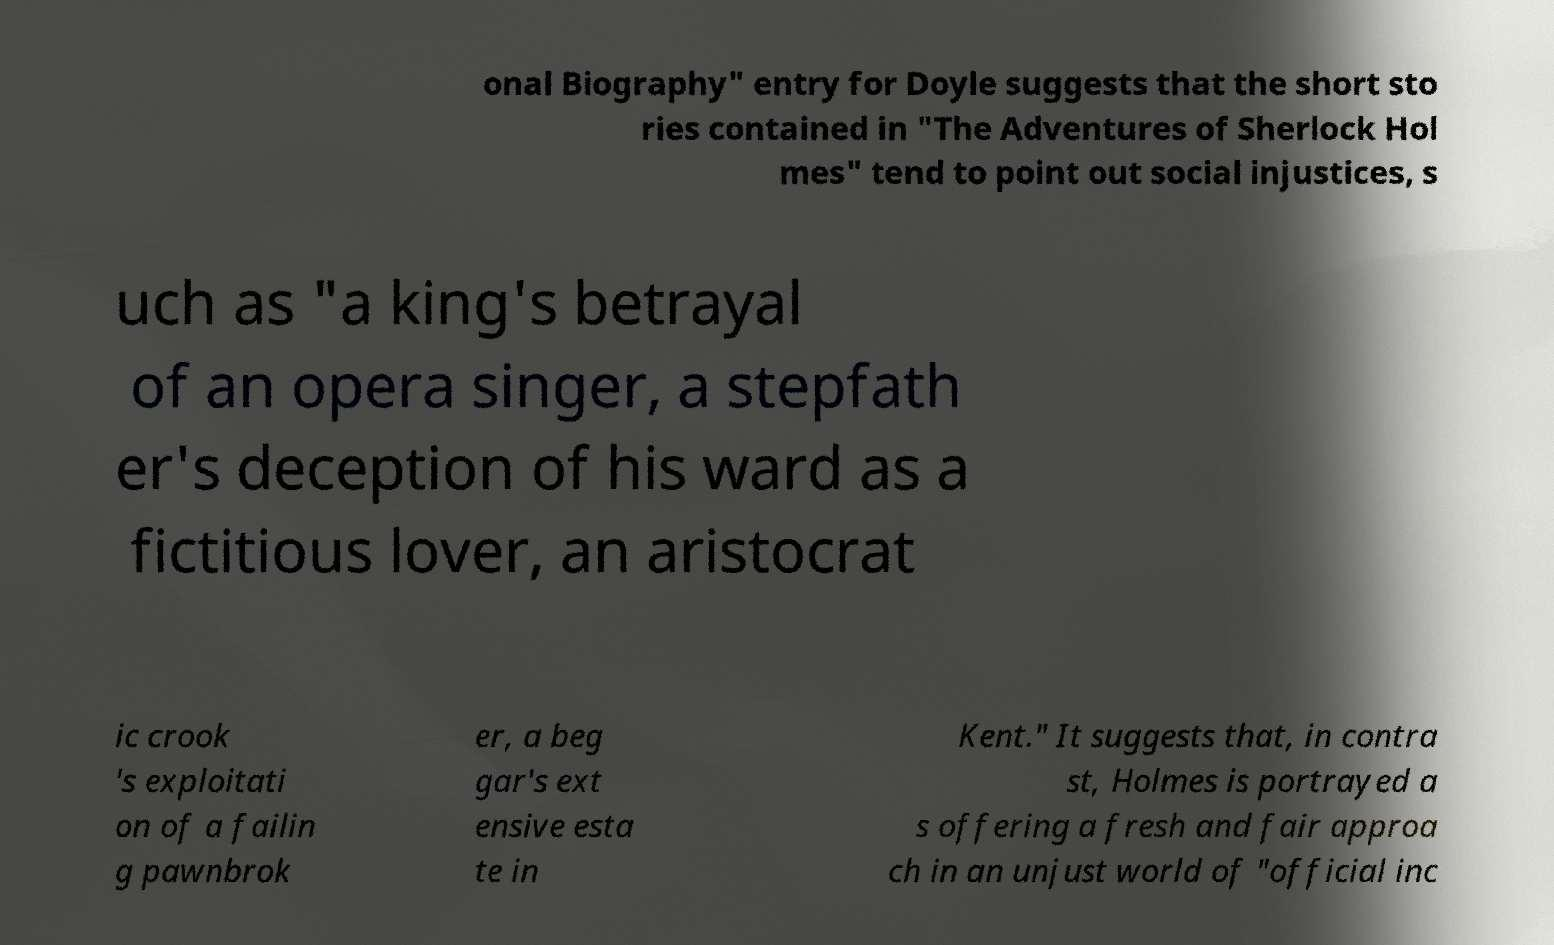What messages or text are displayed in this image? I need them in a readable, typed format. onal Biography" entry for Doyle suggests that the short sto ries contained in "The Adventures of Sherlock Hol mes" tend to point out social injustices, s uch as "a king's betrayal of an opera singer, a stepfath er's deception of his ward as a fictitious lover, an aristocrat ic crook 's exploitati on of a failin g pawnbrok er, a beg gar's ext ensive esta te in Kent." It suggests that, in contra st, Holmes is portrayed a s offering a fresh and fair approa ch in an unjust world of "official inc 